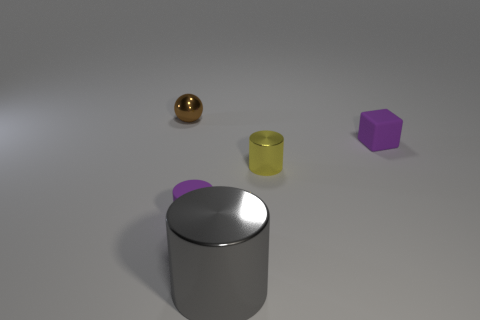Subtract all gray metallic cylinders. How many cylinders are left? 2 Add 3 small brown metallic cubes. How many objects exist? 8 Subtract all spheres. How many objects are left? 4 Add 1 yellow things. How many yellow things are left? 2 Add 1 green rubber cubes. How many green rubber cubes exist? 1 Subtract 0 cyan cylinders. How many objects are left? 5 Subtract all red cylinders. Subtract all purple cubes. How many cylinders are left? 3 Subtract all brown metal balls. Subtract all tiny purple rubber blocks. How many objects are left? 3 